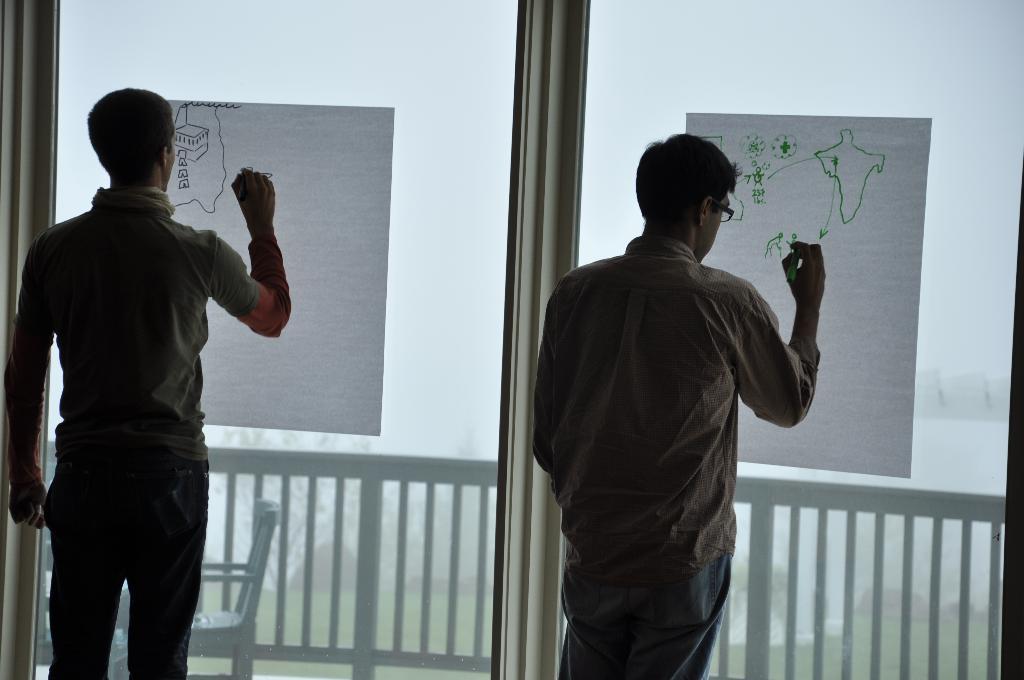Please provide a concise description of this image. In this image I can see two men are standing and I can see both of them are holding markers. I can also see few papers and on these papers I can see few drawings. In the background I can see a white colour chair. 